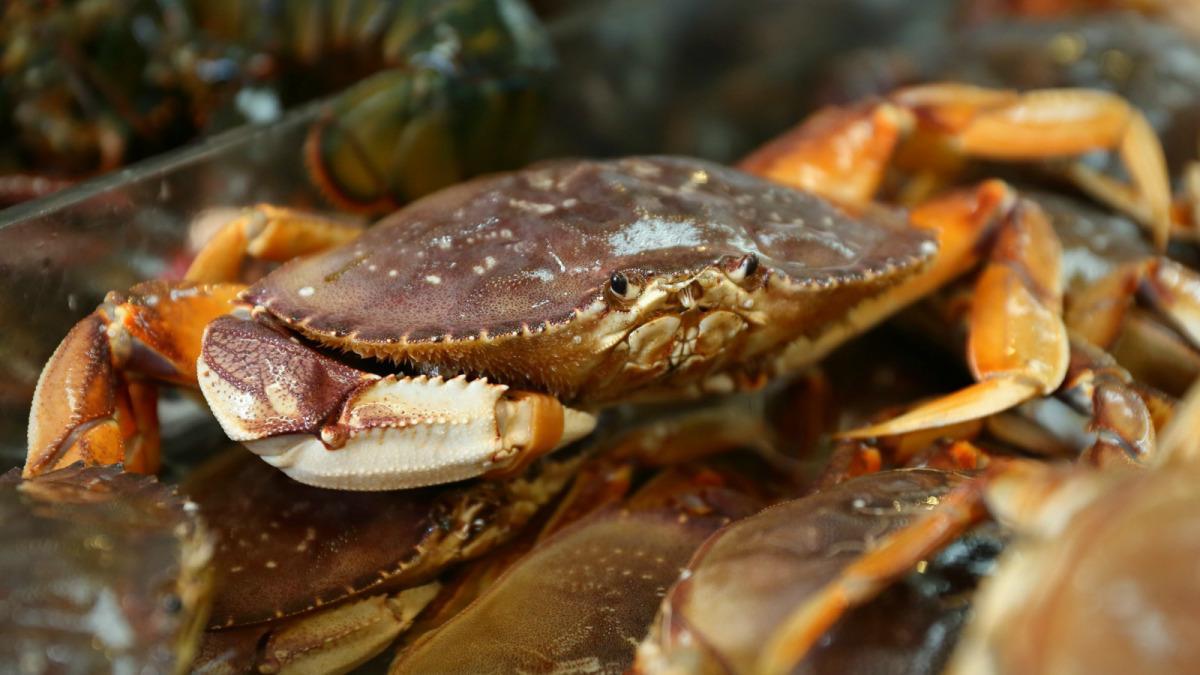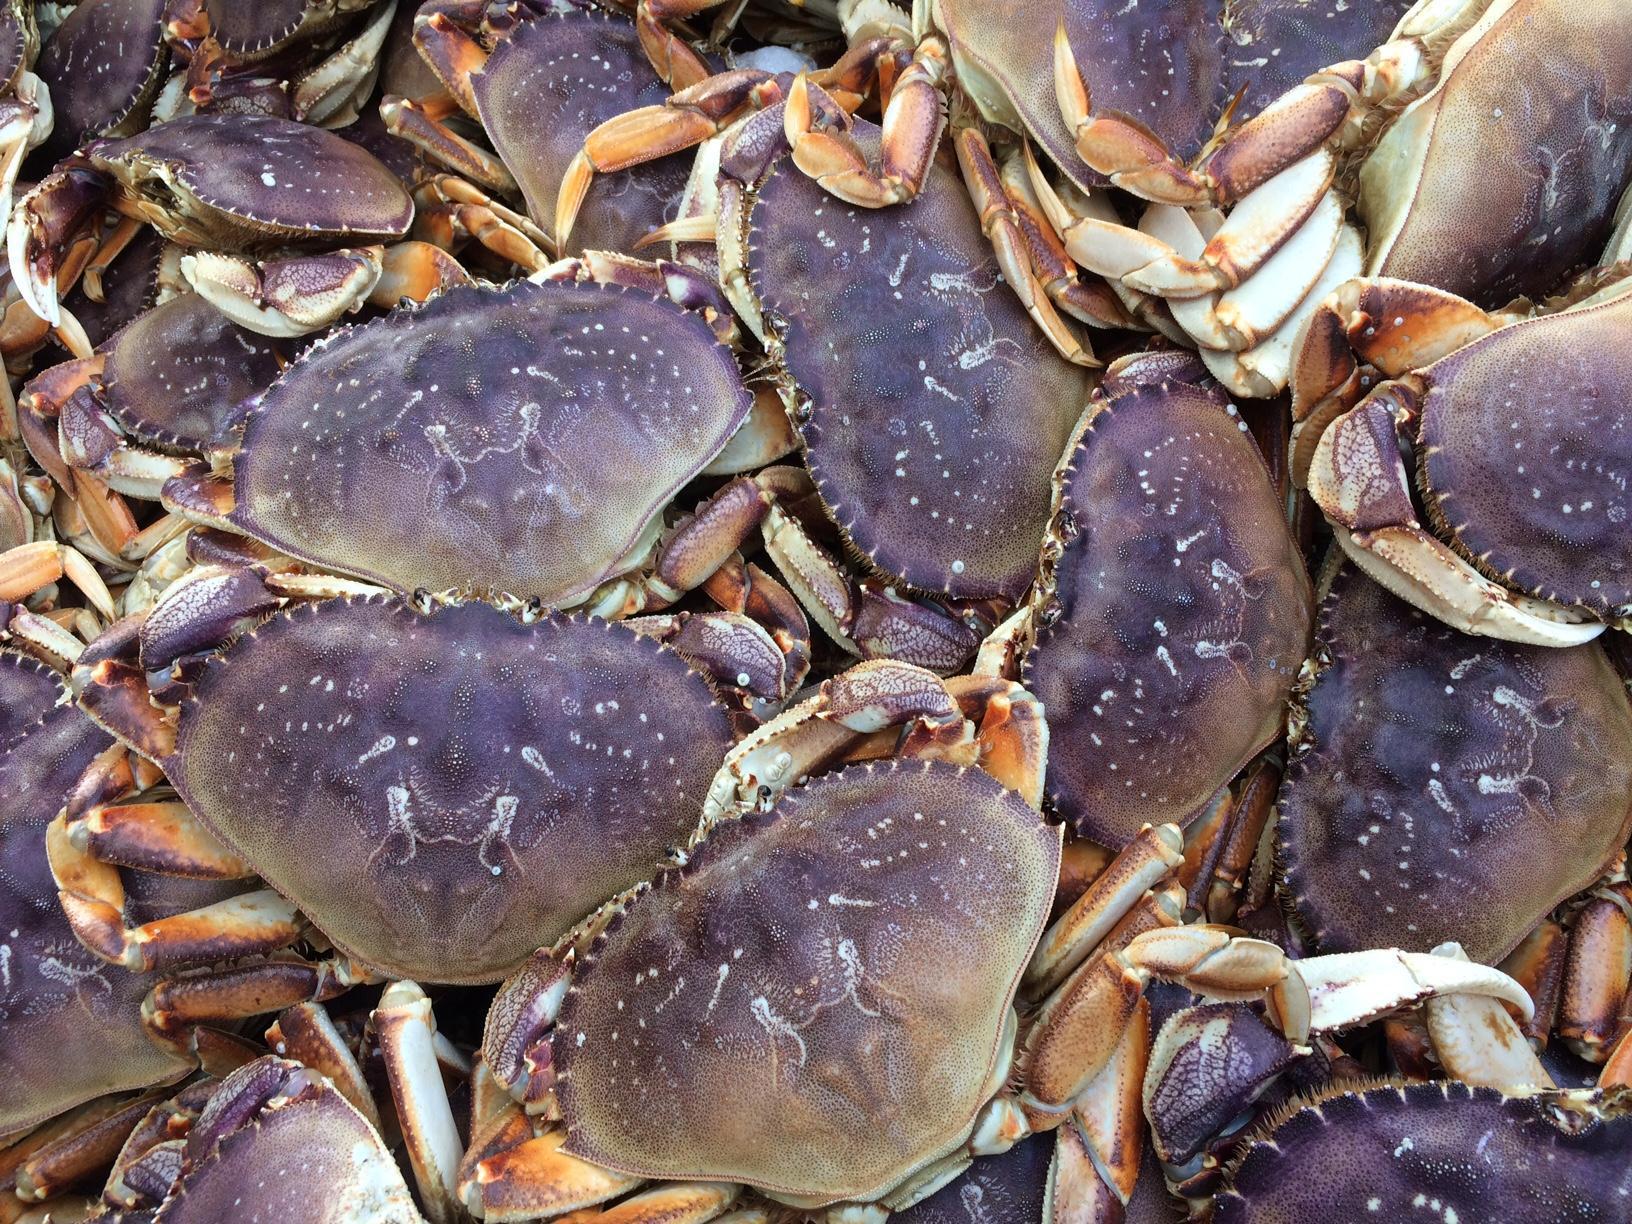The first image is the image on the left, the second image is the image on the right. Analyze the images presented: Is the assertion "One of the images features exactly one crab." valid? Answer yes or no. No. 